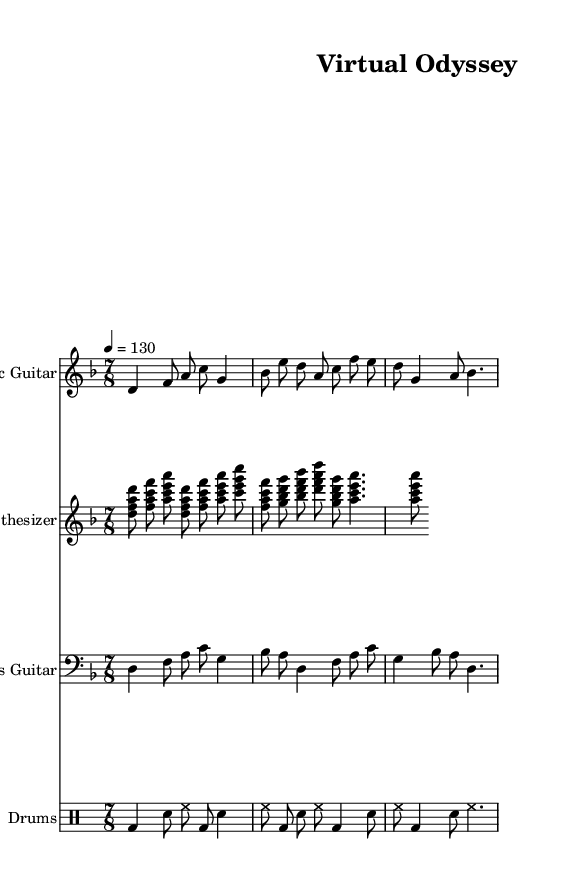What is the key signature of this music? The key signature is indicated by the sharp or flat symbols at the beginning of the staff. In this case, it shows two flats (B♭ and E♭), which characterizes the D minor key signature.
Answer: D minor What is the time signature of this music? The time signature is found at the beginning of the piece and indicates how many beats are in each measure. Here, it shows 7/8, which means there are seven eighth notes per measure.
Answer: 7/8 What is the tempo marking of this piece? The tempo is specified within the score and indicates how fast the music should be played. Here, it indicates a tempo of 130 beats per minute, which is noted in the score directly after the time signature.
Answer: 130 What instrument plays the melody primarily? The melody can often be found in the upper staff of the score; here, it is played by the Electric Guitar, which is indicated by the staff label.
Answer: Electric Guitar How many measures are present in the Electric Guitar part? To determine the number of measures, you would count each horizontal segment between the bar lines in the Electric Guitar part. The provided section contains three measures in the Electric Guitar.
Answer: 3 Explain the rhythmic feel of this composition in terms of the time signature. The 7/8 time signature indicates an uneven rhythmic feel. In typical 7/8, the beats could be grouped as 2+2+3 or 3+2+2, creating a distinct progressive rock groove, as seen in the way the notes are arranged over the measures. This results in a driving yet unpredictable rhythm, typical of progressive rock music.
Answer: Uneven, progressive rock groove 